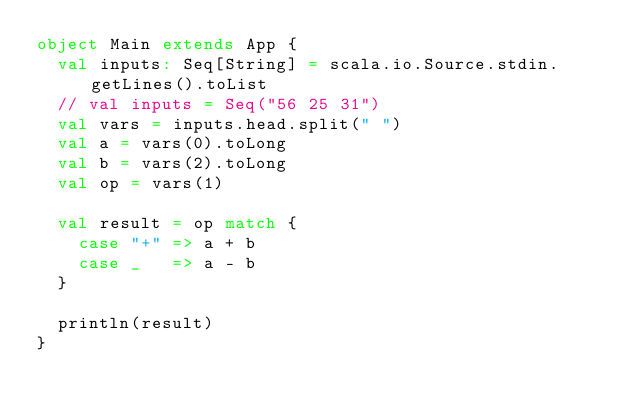<code> <loc_0><loc_0><loc_500><loc_500><_Scala_>object Main extends App {
  val inputs: Seq[String] = scala.io.Source.stdin.getLines().toList
  // val inputs = Seq("56 25 31")
  val vars = inputs.head.split(" ")
  val a = vars(0).toLong
  val b = vars(2).toLong
  val op = vars(1)

  val result = op match {
    case "+" => a + b
    case _   => a - b
  }

  println(result)
}</code> 